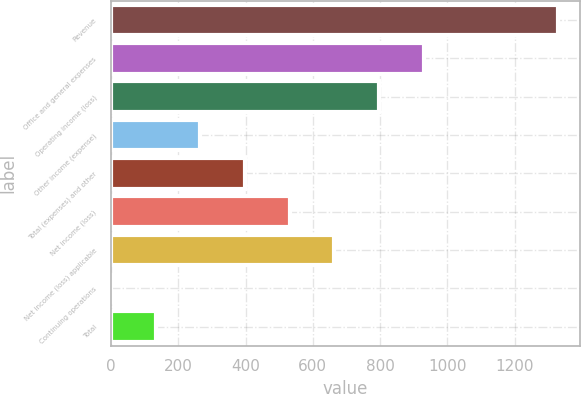Convert chart. <chart><loc_0><loc_0><loc_500><loc_500><bar_chart><fcel>Revenue<fcel>Office and general expenses<fcel>Operating income (loss)<fcel>Other income (expense)<fcel>Total (expenses) and other<fcel>Net income (loss)<fcel>Net income (loss) applicable<fcel>Continuing operations<fcel>Total<nl><fcel>1328.2<fcel>929.82<fcel>797.04<fcel>265.92<fcel>398.7<fcel>531.48<fcel>664.26<fcel>0.36<fcel>133.14<nl></chart> 